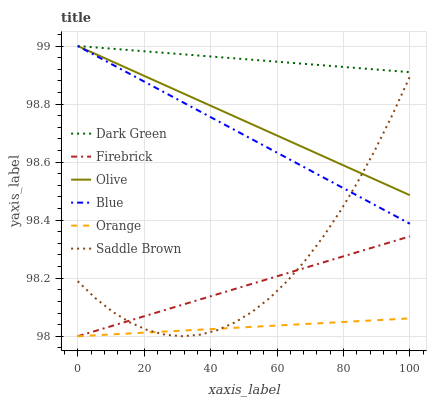Does Orange have the minimum area under the curve?
Answer yes or no. Yes. Does Dark Green have the maximum area under the curve?
Answer yes or no. Yes. Does Firebrick have the minimum area under the curve?
Answer yes or no. No. Does Firebrick have the maximum area under the curve?
Answer yes or no. No. Is Blue the smoothest?
Answer yes or no. Yes. Is Saddle Brown the roughest?
Answer yes or no. Yes. Is Firebrick the smoothest?
Answer yes or no. No. Is Firebrick the roughest?
Answer yes or no. No. Does Firebrick have the lowest value?
Answer yes or no. Yes. Does Olive have the lowest value?
Answer yes or no. No. Does Dark Green have the highest value?
Answer yes or no. Yes. Does Firebrick have the highest value?
Answer yes or no. No. Is Orange less than Olive?
Answer yes or no. Yes. Is Olive greater than Firebrick?
Answer yes or no. Yes. Does Olive intersect Dark Green?
Answer yes or no. Yes. Is Olive less than Dark Green?
Answer yes or no. No. Is Olive greater than Dark Green?
Answer yes or no. No. Does Orange intersect Olive?
Answer yes or no. No. 